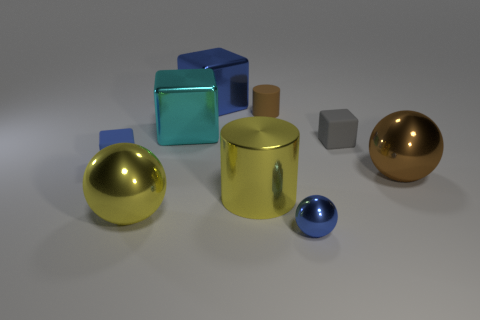The metal sphere that is behind the sphere left of the large blue cube is what color? The color of the metal sphere situated behind the sphere to the left of the large blue cube appears to be a golden hue, reflecting the soft light in its environment. 